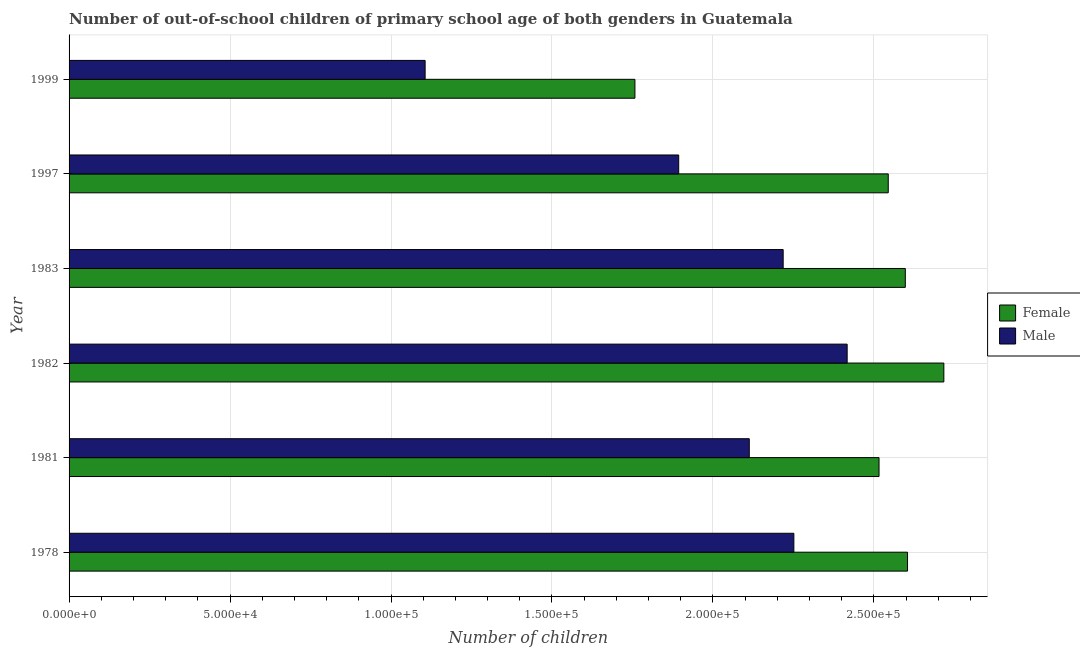How many groups of bars are there?
Give a very brief answer. 6. Are the number of bars on each tick of the Y-axis equal?
Offer a very short reply. Yes. How many bars are there on the 3rd tick from the top?
Give a very brief answer. 2. What is the number of male out-of-school students in 1983?
Give a very brief answer. 2.22e+05. Across all years, what is the maximum number of male out-of-school students?
Provide a short and direct response. 2.42e+05. Across all years, what is the minimum number of male out-of-school students?
Provide a short and direct response. 1.11e+05. In which year was the number of male out-of-school students maximum?
Offer a terse response. 1982. What is the total number of male out-of-school students in the graph?
Provide a succinct answer. 1.20e+06. What is the difference between the number of male out-of-school students in 1983 and that in 1999?
Give a very brief answer. 1.11e+05. What is the difference between the number of male out-of-school students in 1983 and the number of female out-of-school students in 1978?
Offer a terse response. -3.86e+04. What is the average number of female out-of-school students per year?
Offer a very short reply. 2.46e+05. In the year 1999, what is the difference between the number of female out-of-school students and number of male out-of-school students?
Provide a succinct answer. 6.52e+04. In how many years, is the number of female out-of-school students greater than 140000 ?
Provide a succinct answer. 6. What is the ratio of the number of female out-of-school students in 1978 to that in 1999?
Your response must be concise. 1.48. Is the difference between the number of female out-of-school students in 1978 and 1983 greater than the difference between the number of male out-of-school students in 1978 and 1983?
Provide a short and direct response. No. What is the difference between the highest and the second highest number of female out-of-school students?
Your answer should be compact. 1.13e+04. What is the difference between the highest and the lowest number of male out-of-school students?
Keep it short and to the point. 1.31e+05. What does the 1st bar from the top in 1981 represents?
Your answer should be compact. Male. How many years are there in the graph?
Provide a short and direct response. 6. Are the values on the major ticks of X-axis written in scientific E-notation?
Give a very brief answer. Yes. How many legend labels are there?
Keep it short and to the point. 2. How are the legend labels stacked?
Your answer should be compact. Vertical. What is the title of the graph?
Your response must be concise. Number of out-of-school children of primary school age of both genders in Guatemala. What is the label or title of the X-axis?
Your answer should be very brief. Number of children. What is the Number of children in Female in 1978?
Keep it short and to the point. 2.60e+05. What is the Number of children of Male in 1978?
Offer a very short reply. 2.25e+05. What is the Number of children in Female in 1981?
Offer a terse response. 2.52e+05. What is the Number of children of Male in 1981?
Offer a very short reply. 2.11e+05. What is the Number of children of Female in 1982?
Offer a very short reply. 2.72e+05. What is the Number of children of Male in 1982?
Keep it short and to the point. 2.42e+05. What is the Number of children of Female in 1983?
Your answer should be very brief. 2.60e+05. What is the Number of children in Male in 1983?
Your answer should be very brief. 2.22e+05. What is the Number of children in Female in 1997?
Your response must be concise. 2.54e+05. What is the Number of children of Male in 1997?
Provide a succinct answer. 1.89e+05. What is the Number of children of Female in 1999?
Give a very brief answer. 1.76e+05. What is the Number of children of Male in 1999?
Your answer should be compact. 1.11e+05. Across all years, what is the maximum Number of children of Female?
Your answer should be compact. 2.72e+05. Across all years, what is the maximum Number of children in Male?
Your response must be concise. 2.42e+05. Across all years, what is the minimum Number of children in Female?
Offer a terse response. 1.76e+05. Across all years, what is the minimum Number of children of Male?
Your answer should be very brief. 1.11e+05. What is the total Number of children in Female in the graph?
Your answer should be very brief. 1.47e+06. What is the total Number of children of Male in the graph?
Provide a succinct answer. 1.20e+06. What is the difference between the Number of children in Female in 1978 and that in 1981?
Provide a succinct answer. 8850. What is the difference between the Number of children in Male in 1978 and that in 1981?
Offer a terse response. 1.38e+04. What is the difference between the Number of children in Female in 1978 and that in 1982?
Provide a short and direct response. -1.13e+04. What is the difference between the Number of children in Male in 1978 and that in 1982?
Keep it short and to the point. -1.66e+04. What is the difference between the Number of children in Female in 1978 and that in 1983?
Offer a terse response. 689. What is the difference between the Number of children of Male in 1978 and that in 1983?
Your answer should be compact. 3320. What is the difference between the Number of children in Female in 1978 and that in 1997?
Offer a terse response. 5988. What is the difference between the Number of children of Male in 1978 and that in 1997?
Your answer should be compact. 3.58e+04. What is the difference between the Number of children in Female in 1978 and that in 1999?
Provide a short and direct response. 8.47e+04. What is the difference between the Number of children in Male in 1978 and that in 1999?
Provide a succinct answer. 1.15e+05. What is the difference between the Number of children of Female in 1981 and that in 1982?
Your answer should be very brief. -2.01e+04. What is the difference between the Number of children of Male in 1981 and that in 1982?
Make the answer very short. -3.04e+04. What is the difference between the Number of children in Female in 1981 and that in 1983?
Provide a succinct answer. -8161. What is the difference between the Number of children of Male in 1981 and that in 1983?
Keep it short and to the point. -1.05e+04. What is the difference between the Number of children in Female in 1981 and that in 1997?
Give a very brief answer. -2862. What is the difference between the Number of children in Male in 1981 and that in 1997?
Ensure brevity in your answer.  2.19e+04. What is the difference between the Number of children in Female in 1981 and that in 1999?
Keep it short and to the point. 7.58e+04. What is the difference between the Number of children of Male in 1981 and that in 1999?
Offer a very short reply. 1.01e+05. What is the difference between the Number of children of Female in 1982 and that in 1983?
Provide a succinct answer. 1.20e+04. What is the difference between the Number of children of Male in 1982 and that in 1983?
Your answer should be compact. 1.99e+04. What is the difference between the Number of children of Female in 1982 and that in 1997?
Offer a terse response. 1.73e+04. What is the difference between the Number of children of Male in 1982 and that in 1997?
Make the answer very short. 5.23e+04. What is the difference between the Number of children in Female in 1982 and that in 1999?
Offer a terse response. 9.60e+04. What is the difference between the Number of children of Male in 1982 and that in 1999?
Provide a succinct answer. 1.31e+05. What is the difference between the Number of children in Female in 1983 and that in 1997?
Provide a short and direct response. 5299. What is the difference between the Number of children of Male in 1983 and that in 1997?
Offer a terse response. 3.25e+04. What is the difference between the Number of children in Female in 1983 and that in 1999?
Offer a very short reply. 8.40e+04. What is the difference between the Number of children of Male in 1983 and that in 1999?
Provide a short and direct response. 1.11e+05. What is the difference between the Number of children of Female in 1997 and that in 1999?
Your answer should be compact. 7.87e+04. What is the difference between the Number of children of Male in 1997 and that in 1999?
Provide a short and direct response. 7.88e+04. What is the difference between the Number of children of Female in 1978 and the Number of children of Male in 1981?
Offer a terse response. 4.92e+04. What is the difference between the Number of children of Female in 1978 and the Number of children of Male in 1982?
Provide a short and direct response. 1.88e+04. What is the difference between the Number of children in Female in 1978 and the Number of children in Male in 1983?
Offer a very short reply. 3.86e+04. What is the difference between the Number of children in Female in 1978 and the Number of children in Male in 1997?
Ensure brevity in your answer.  7.11e+04. What is the difference between the Number of children of Female in 1978 and the Number of children of Male in 1999?
Provide a succinct answer. 1.50e+05. What is the difference between the Number of children of Female in 1981 and the Number of children of Male in 1982?
Your answer should be very brief. 9901. What is the difference between the Number of children in Female in 1981 and the Number of children in Male in 1983?
Keep it short and to the point. 2.98e+04. What is the difference between the Number of children in Female in 1981 and the Number of children in Male in 1997?
Provide a short and direct response. 6.22e+04. What is the difference between the Number of children in Female in 1981 and the Number of children in Male in 1999?
Offer a terse response. 1.41e+05. What is the difference between the Number of children of Female in 1982 and the Number of children of Male in 1983?
Make the answer very short. 4.99e+04. What is the difference between the Number of children of Female in 1982 and the Number of children of Male in 1997?
Your response must be concise. 8.24e+04. What is the difference between the Number of children of Female in 1982 and the Number of children of Male in 1999?
Your response must be concise. 1.61e+05. What is the difference between the Number of children of Female in 1983 and the Number of children of Male in 1997?
Your response must be concise. 7.04e+04. What is the difference between the Number of children of Female in 1983 and the Number of children of Male in 1999?
Your answer should be compact. 1.49e+05. What is the difference between the Number of children in Female in 1997 and the Number of children in Male in 1999?
Provide a short and direct response. 1.44e+05. What is the average Number of children of Female per year?
Offer a terse response. 2.46e+05. What is the average Number of children of Male per year?
Make the answer very short. 2.00e+05. In the year 1978, what is the difference between the Number of children of Female and Number of children of Male?
Offer a very short reply. 3.53e+04. In the year 1981, what is the difference between the Number of children in Female and Number of children in Male?
Your response must be concise. 4.03e+04. In the year 1982, what is the difference between the Number of children of Female and Number of children of Male?
Your answer should be compact. 3.00e+04. In the year 1983, what is the difference between the Number of children of Female and Number of children of Male?
Offer a terse response. 3.79e+04. In the year 1997, what is the difference between the Number of children of Female and Number of children of Male?
Your answer should be very brief. 6.51e+04. In the year 1999, what is the difference between the Number of children of Female and Number of children of Male?
Offer a very short reply. 6.52e+04. What is the ratio of the Number of children of Female in 1978 to that in 1981?
Give a very brief answer. 1.04. What is the ratio of the Number of children in Male in 1978 to that in 1981?
Provide a short and direct response. 1.07. What is the ratio of the Number of children of Female in 1978 to that in 1982?
Give a very brief answer. 0.96. What is the ratio of the Number of children of Male in 1978 to that in 1982?
Your answer should be very brief. 0.93. What is the ratio of the Number of children in Female in 1978 to that in 1983?
Ensure brevity in your answer.  1. What is the ratio of the Number of children of Male in 1978 to that in 1983?
Make the answer very short. 1.01. What is the ratio of the Number of children in Female in 1978 to that in 1997?
Provide a short and direct response. 1.02. What is the ratio of the Number of children in Male in 1978 to that in 1997?
Give a very brief answer. 1.19. What is the ratio of the Number of children in Female in 1978 to that in 1999?
Offer a very short reply. 1.48. What is the ratio of the Number of children in Male in 1978 to that in 1999?
Ensure brevity in your answer.  2.04. What is the ratio of the Number of children of Female in 1981 to that in 1982?
Your response must be concise. 0.93. What is the ratio of the Number of children of Male in 1981 to that in 1982?
Offer a very short reply. 0.87. What is the ratio of the Number of children in Female in 1981 to that in 1983?
Provide a short and direct response. 0.97. What is the ratio of the Number of children of Male in 1981 to that in 1983?
Give a very brief answer. 0.95. What is the ratio of the Number of children of Female in 1981 to that in 1997?
Make the answer very short. 0.99. What is the ratio of the Number of children in Male in 1981 to that in 1997?
Make the answer very short. 1.12. What is the ratio of the Number of children of Female in 1981 to that in 1999?
Your answer should be compact. 1.43. What is the ratio of the Number of children in Male in 1981 to that in 1999?
Keep it short and to the point. 1.91. What is the ratio of the Number of children in Female in 1982 to that in 1983?
Make the answer very short. 1.05. What is the ratio of the Number of children of Male in 1982 to that in 1983?
Offer a very short reply. 1.09. What is the ratio of the Number of children of Female in 1982 to that in 1997?
Give a very brief answer. 1.07. What is the ratio of the Number of children of Male in 1982 to that in 1997?
Make the answer very short. 1.28. What is the ratio of the Number of children in Female in 1982 to that in 1999?
Your answer should be very brief. 1.55. What is the ratio of the Number of children of Male in 1982 to that in 1999?
Offer a terse response. 2.19. What is the ratio of the Number of children in Female in 1983 to that in 1997?
Make the answer very short. 1.02. What is the ratio of the Number of children in Male in 1983 to that in 1997?
Your answer should be very brief. 1.17. What is the ratio of the Number of children in Female in 1983 to that in 1999?
Keep it short and to the point. 1.48. What is the ratio of the Number of children in Male in 1983 to that in 1999?
Offer a terse response. 2.01. What is the ratio of the Number of children in Female in 1997 to that in 1999?
Provide a succinct answer. 1.45. What is the ratio of the Number of children of Male in 1997 to that in 1999?
Offer a terse response. 1.71. What is the difference between the highest and the second highest Number of children in Female?
Provide a short and direct response. 1.13e+04. What is the difference between the highest and the second highest Number of children in Male?
Provide a short and direct response. 1.66e+04. What is the difference between the highest and the lowest Number of children in Female?
Provide a short and direct response. 9.60e+04. What is the difference between the highest and the lowest Number of children of Male?
Provide a succinct answer. 1.31e+05. 